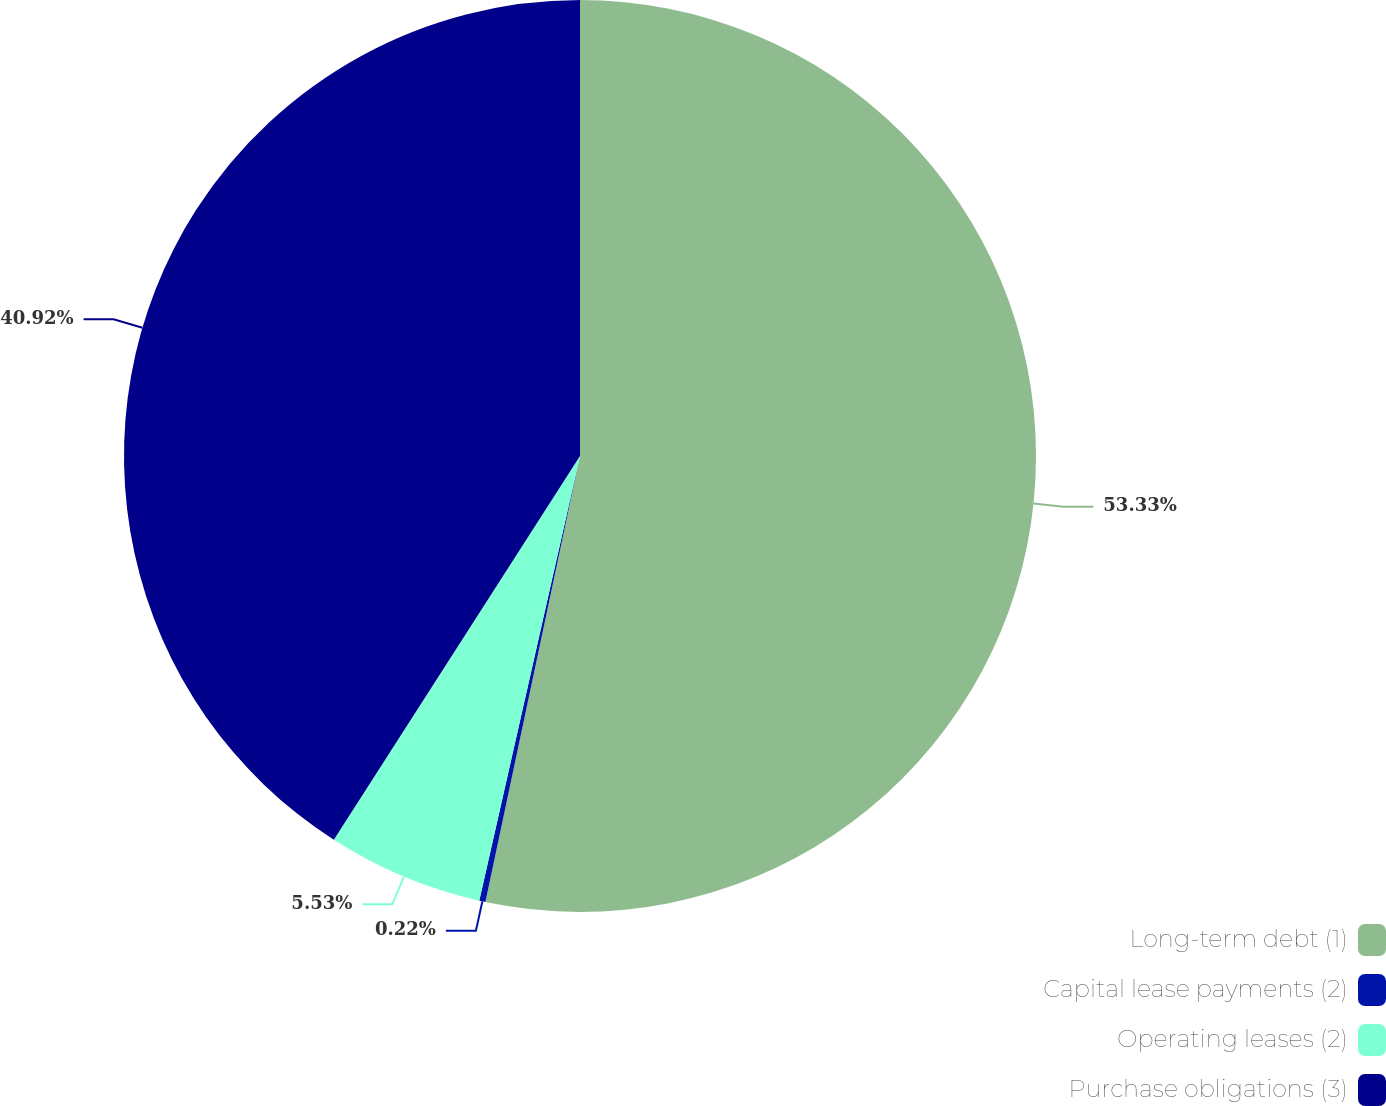<chart> <loc_0><loc_0><loc_500><loc_500><pie_chart><fcel>Long-term debt (1)<fcel>Capital lease payments (2)<fcel>Operating leases (2)<fcel>Purchase obligations (3)<nl><fcel>53.32%<fcel>0.22%<fcel>5.53%<fcel>40.92%<nl></chart> 